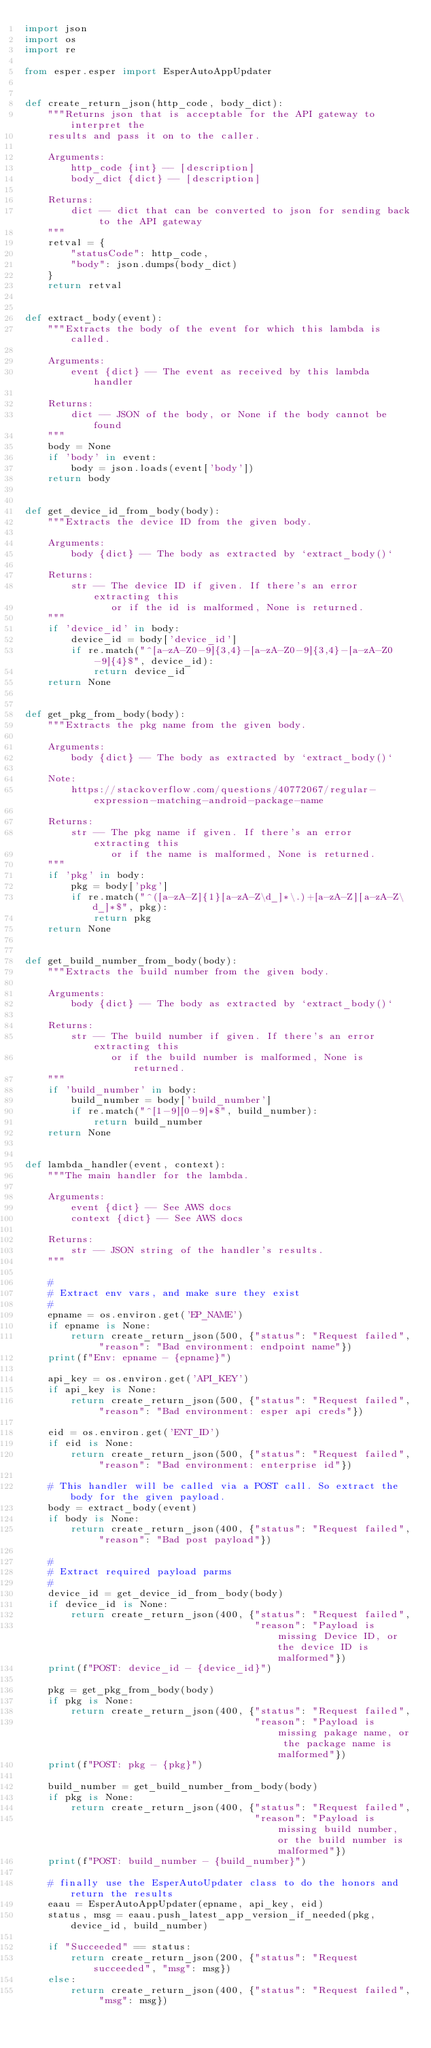Convert code to text. <code><loc_0><loc_0><loc_500><loc_500><_Python_>import json
import os
import re

from esper.esper import EsperAutoAppUpdater


def create_return_json(http_code, body_dict):
    """Returns json that is acceptable for the API gateway to interpret the
    results and pass it on to the caller.
    
    Arguments:
        http_code {int} -- [description]
        body_dict {dict} -- [description]
    
    Returns:
        dict -- dict that can be converted to json for sending back to the API gateway
    """
    retval = {
        "statusCode": http_code,
        "body": json.dumps(body_dict)
    }
    return retval


def extract_body(event):
    """Extracts the body of the event for which this lambda is called.
    
    Arguments:
        event {dict} -- The event as received by this lambda handler
    
    Returns:
        dict -- JSON of the body, or None if the body cannot be found
    """
    body = None
    if 'body' in event:
        body = json.loads(event['body'])
    return body


def get_device_id_from_body(body):
    """Extracts the device ID from the given body.
    
    Arguments:
        body {dict} -- The body as extracted by `extract_body()`
    
    Returns:
        str -- The device ID if given. If there's an error extracting this
               or if the id is malformed, None is returned.
    """
    if 'device_id' in body:
        device_id = body['device_id']
        if re.match("^[a-zA-Z0-9]{3,4}-[a-zA-Z0-9]{3,4}-[a-zA-Z0-9]{4}$", device_id):
            return device_id
    return None


def get_pkg_from_body(body):
    """Extracts the pkg name from the given body.
    
    Arguments:
        body {dict} -- The body as extracted by `extract_body()`
    
    Note:
        https://stackoverflow.com/questions/40772067/regular-expression-matching-android-package-name

    Returns:
        str -- The pkg name if given. If there's an error extracting this
               or if the name is malformed, None is returned.
    """
    if 'pkg' in body:
        pkg = body['pkg']
        if re.match("^([a-zA-Z]{1}[a-zA-Z\d_]*\.)+[a-zA-Z][a-zA-Z\d_]*$", pkg):
            return pkg
    return None


def get_build_number_from_body(body):
    """Extracts the build number from the given body.
    
    Arguments:
        body {dict} -- The body as extracted by `extract_body()`
    
    Returns:
        str -- The build number if given. If there's an error extracting this
               or if the build number is malformed, None is returned.
    """
    if 'build_number' in body:
        build_number = body['build_number']
        if re.match("^[1-9][0-9]*$", build_number):
            return build_number
    return None


def lambda_handler(event, context):
    """The main handler for the lambda.
    
    Arguments:
        event {dict} -- See AWS docs
        context {dict} -- See AWS docs
    
    Returns:
        str -- JSON string of the handler's results.
    """

    #
    # Extract env vars, and make sure they exist
    #
    epname = os.environ.get('EP_NAME')
    if epname is None:
        return create_return_json(500, {"status": "Request failed", "reason": "Bad environment: endpoint name"})
    print(f"Env: epname - {epname}")

    api_key = os.environ.get('API_KEY')
    if api_key is None:
        return create_return_json(500, {"status": "Request failed", "reason": "Bad environment: esper api creds"})

    eid = os.environ.get('ENT_ID')
    if eid is None:
        return create_return_json(500, {"status": "Request failed", "reason": "Bad environment: enterprise id"})

    # This handler will be called via a POST call. So extract the body for the given payload.
    body = extract_body(event)
    if body is None:
        return create_return_json(400, {"status": "Request failed", "reason": "Bad post payload"})

    #
    # Extract required payload parms
    #
    device_id = get_device_id_from_body(body)
    if device_id is None:
        return create_return_json(400, {"status": "Request failed",
                                        "reason": "Payload is missing Device ID, or the device ID is malformed"})
    print(f"POST: device_id - {device_id}")

    pkg = get_pkg_from_body(body)
    if pkg is None:
        return create_return_json(400, {"status": "Request failed",
                                        "reason": "Payload is missing pakage name, or the package name is malformed"})
    print(f"POST: pkg - {pkg}")

    build_number = get_build_number_from_body(body)
    if pkg is None:
        return create_return_json(400, {"status": "Request failed",
                                        "reason": "Payload is missing build number, or the build number is malformed"})
    print(f"POST: build_number - {build_number}")

    # finally use the EsperAutoUpdater class to do the honors and return the results
    eaau = EsperAutoAppUpdater(epname, api_key, eid)
    status, msg = eaau.push_latest_app_version_if_needed(pkg, device_id, build_number)

    if "Succeeded" == status:
        return create_return_json(200, {"status": "Request succeeded", "msg": msg})
    else:
        return create_return_json(400, {"status": "Request failed", "msg": msg})
</code> 